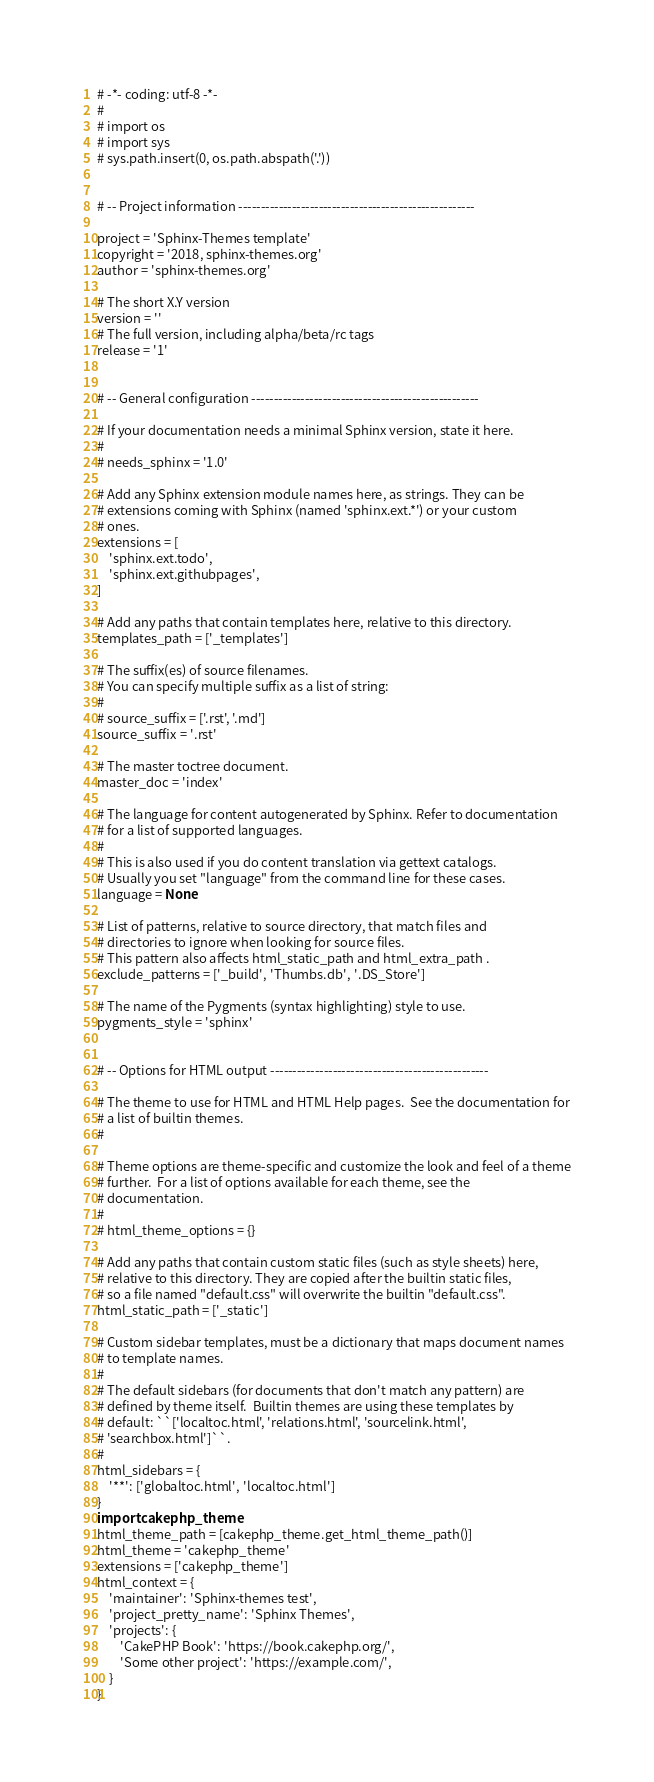<code> <loc_0><loc_0><loc_500><loc_500><_Python_># -*- coding: utf-8 -*-
#
# import os
# import sys
# sys.path.insert(0, os.path.abspath('.'))


# -- Project information -----------------------------------------------------

project = 'Sphinx-Themes template'
copyright = '2018, sphinx-themes.org'
author = 'sphinx-themes.org'

# The short X.Y version
version = ''
# The full version, including alpha/beta/rc tags
release = '1'


# -- General configuration ---------------------------------------------------

# If your documentation needs a minimal Sphinx version, state it here.
#
# needs_sphinx = '1.0'

# Add any Sphinx extension module names here, as strings. They can be
# extensions coming with Sphinx (named 'sphinx.ext.*') or your custom
# ones.
extensions = [
    'sphinx.ext.todo',
    'sphinx.ext.githubpages',
]

# Add any paths that contain templates here, relative to this directory.
templates_path = ['_templates']

# The suffix(es) of source filenames.
# You can specify multiple suffix as a list of string:
#
# source_suffix = ['.rst', '.md']
source_suffix = '.rst'

# The master toctree document.
master_doc = 'index'

# The language for content autogenerated by Sphinx. Refer to documentation
# for a list of supported languages.
#
# This is also used if you do content translation via gettext catalogs.
# Usually you set "language" from the command line for these cases.
language = None

# List of patterns, relative to source directory, that match files and
# directories to ignore when looking for source files.
# This pattern also affects html_static_path and html_extra_path .
exclude_patterns = ['_build', 'Thumbs.db', '.DS_Store']

# The name of the Pygments (syntax highlighting) style to use.
pygments_style = 'sphinx'


# -- Options for HTML output -------------------------------------------------

# The theme to use for HTML and HTML Help pages.  See the documentation for
# a list of builtin themes.
#

# Theme options are theme-specific and customize the look and feel of a theme
# further.  For a list of options available for each theme, see the
# documentation.
#
# html_theme_options = {}

# Add any paths that contain custom static files (such as style sheets) here,
# relative to this directory. They are copied after the builtin static files,
# so a file named "default.css" will overwrite the builtin "default.css".
html_static_path = ['_static']

# Custom sidebar templates, must be a dictionary that maps document names
# to template names.
#
# The default sidebars (for documents that don't match any pattern) are
# defined by theme itself.  Builtin themes are using these templates by
# default: ``['localtoc.html', 'relations.html', 'sourcelink.html',
# 'searchbox.html']``.
#
html_sidebars = {
    '**': ['globaltoc.html', 'localtoc.html']
}
import cakephp_theme
html_theme_path = [cakephp_theme.get_html_theme_path()]
html_theme = 'cakephp_theme'
extensions = ['cakephp_theme']
html_context = {
    'maintainer': 'Sphinx-themes test',
    'project_pretty_name': 'Sphinx Themes',
    'projects': {
        'CakePHP Book': 'https://book.cakephp.org/',
        'Some other project': 'https://example.com/',
    }
}
</code> 